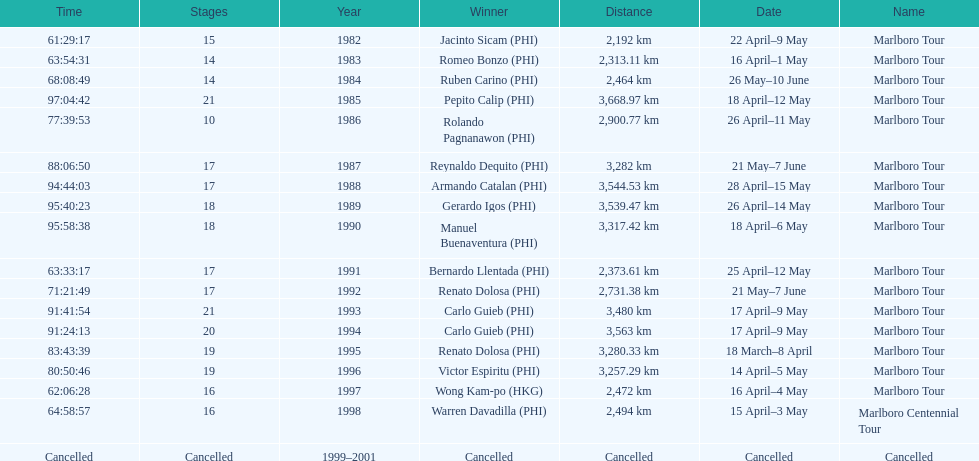Who won the most marlboro tours? Carlo Guieb. 